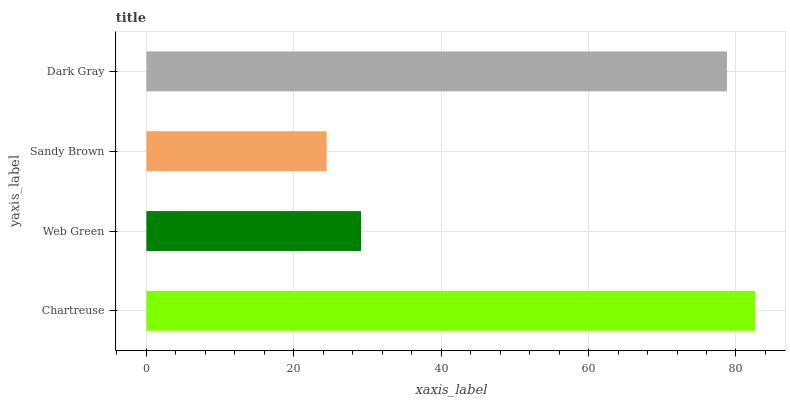Is Sandy Brown the minimum?
Answer yes or no. Yes. Is Chartreuse the maximum?
Answer yes or no. Yes. Is Web Green the minimum?
Answer yes or no. No. Is Web Green the maximum?
Answer yes or no. No. Is Chartreuse greater than Web Green?
Answer yes or no. Yes. Is Web Green less than Chartreuse?
Answer yes or no. Yes. Is Web Green greater than Chartreuse?
Answer yes or no. No. Is Chartreuse less than Web Green?
Answer yes or no. No. Is Dark Gray the high median?
Answer yes or no. Yes. Is Web Green the low median?
Answer yes or no. Yes. Is Sandy Brown the high median?
Answer yes or no. No. Is Dark Gray the low median?
Answer yes or no. No. 